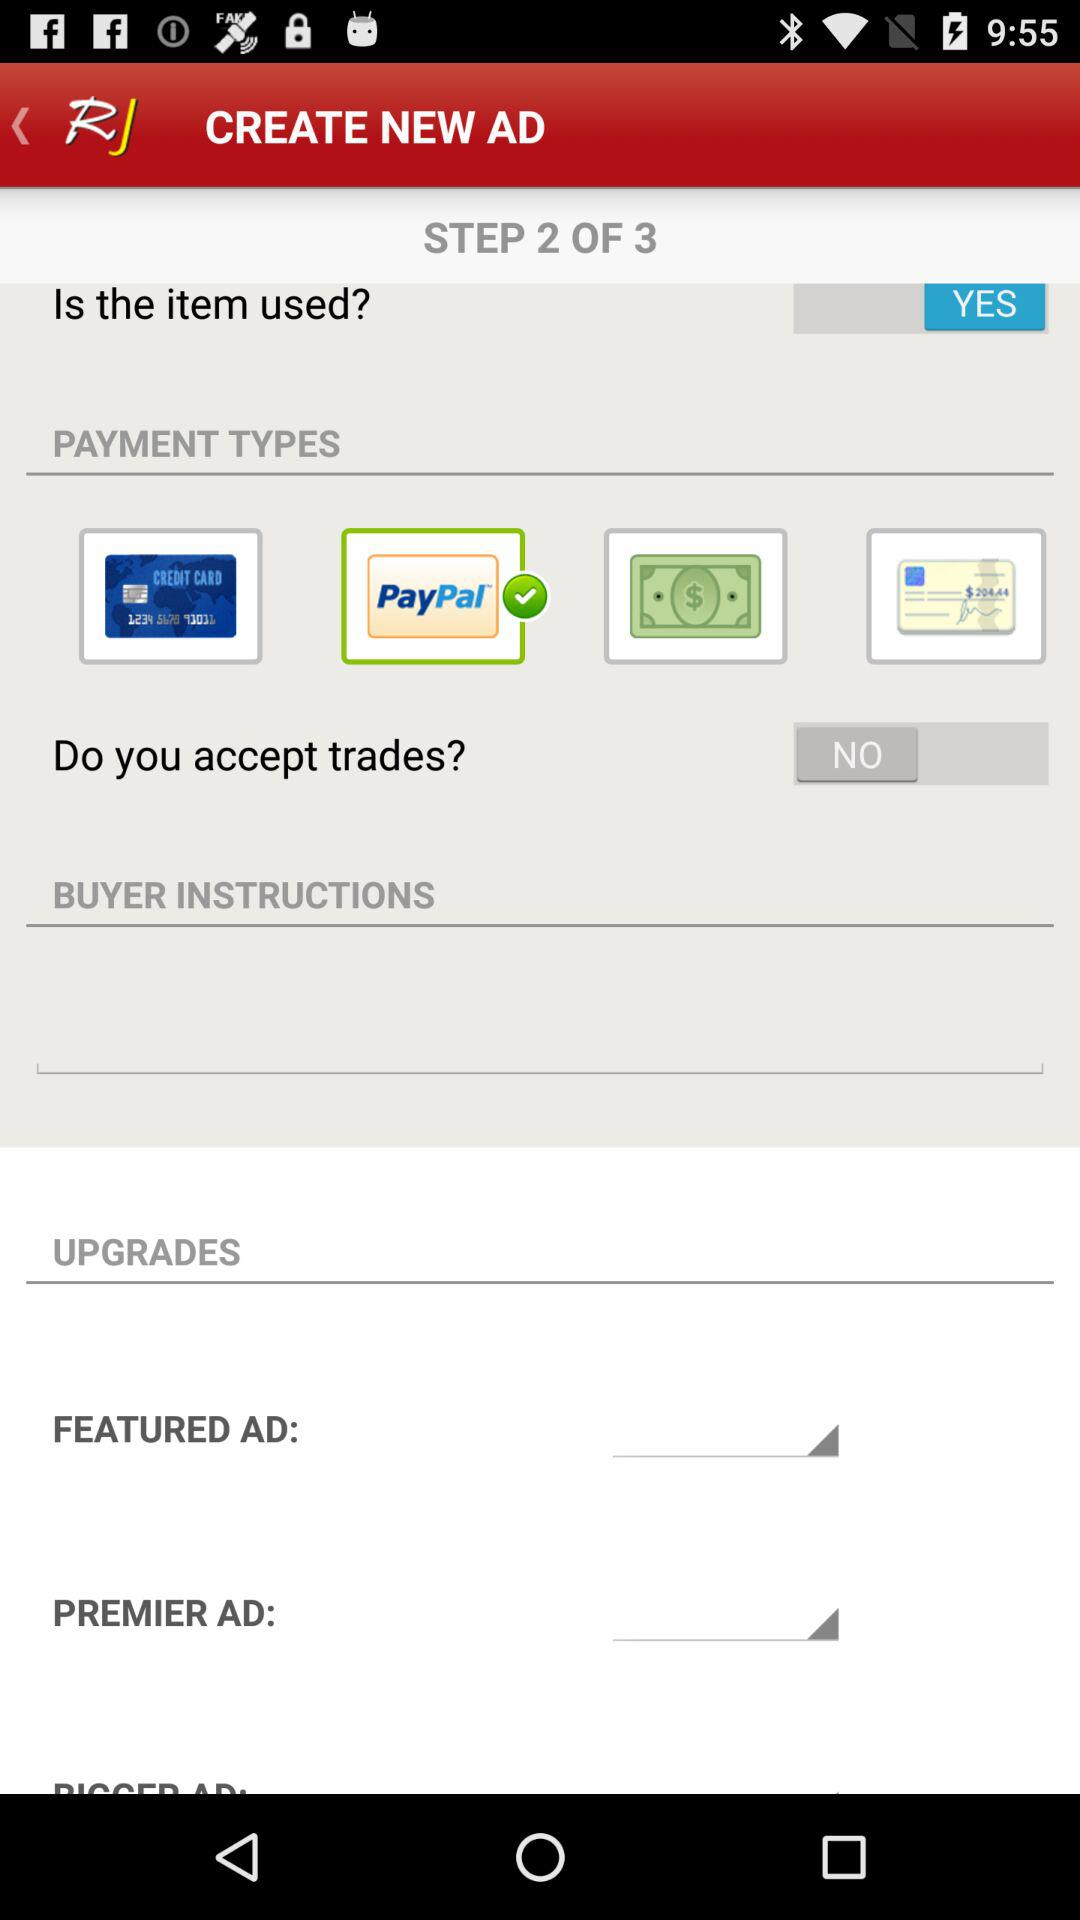Is a private email address required for purchase?
When the provided information is insufficient, respond with <no answer>. <no answer> 